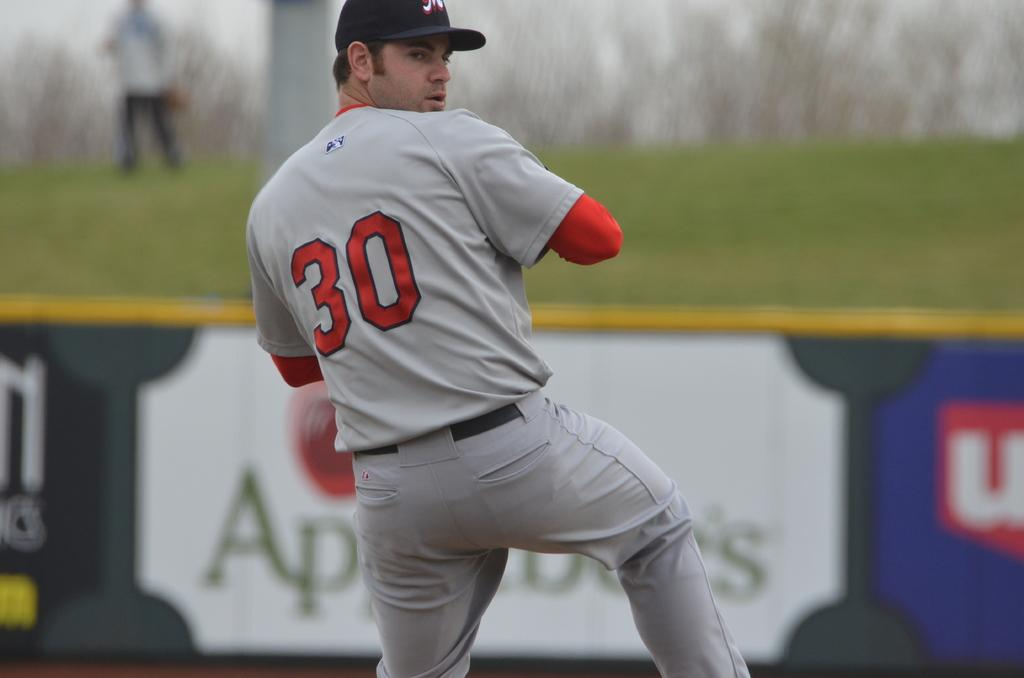<image>
Describe the image concisely. Number 30 is the pitcher and he's about to throw the ball. 